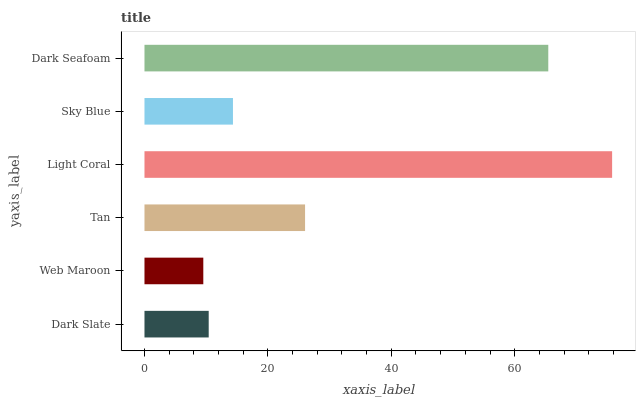Is Web Maroon the minimum?
Answer yes or no. Yes. Is Light Coral the maximum?
Answer yes or no. Yes. Is Tan the minimum?
Answer yes or no. No. Is Tan the maximum?
Answer yes or no. No. Is Tan greater than Web Maroon?
Answer yes or no. Yes. Is Web Maroon less than Tan?
Answer yes or no. Yes. Is Web Maroon greater than Tan?
Answer yes or no. No. Is Tan less than Web Maroon?
Answer yes or no. No. Is Tan the high median?
Answer yes or no. Yes. Is Sky Blue the low median?
Answer yes or no. Yes. Is Web Maroon the high median?
Answer yes or no. No. Is Tan the low median?
Answer yes or no. No. 